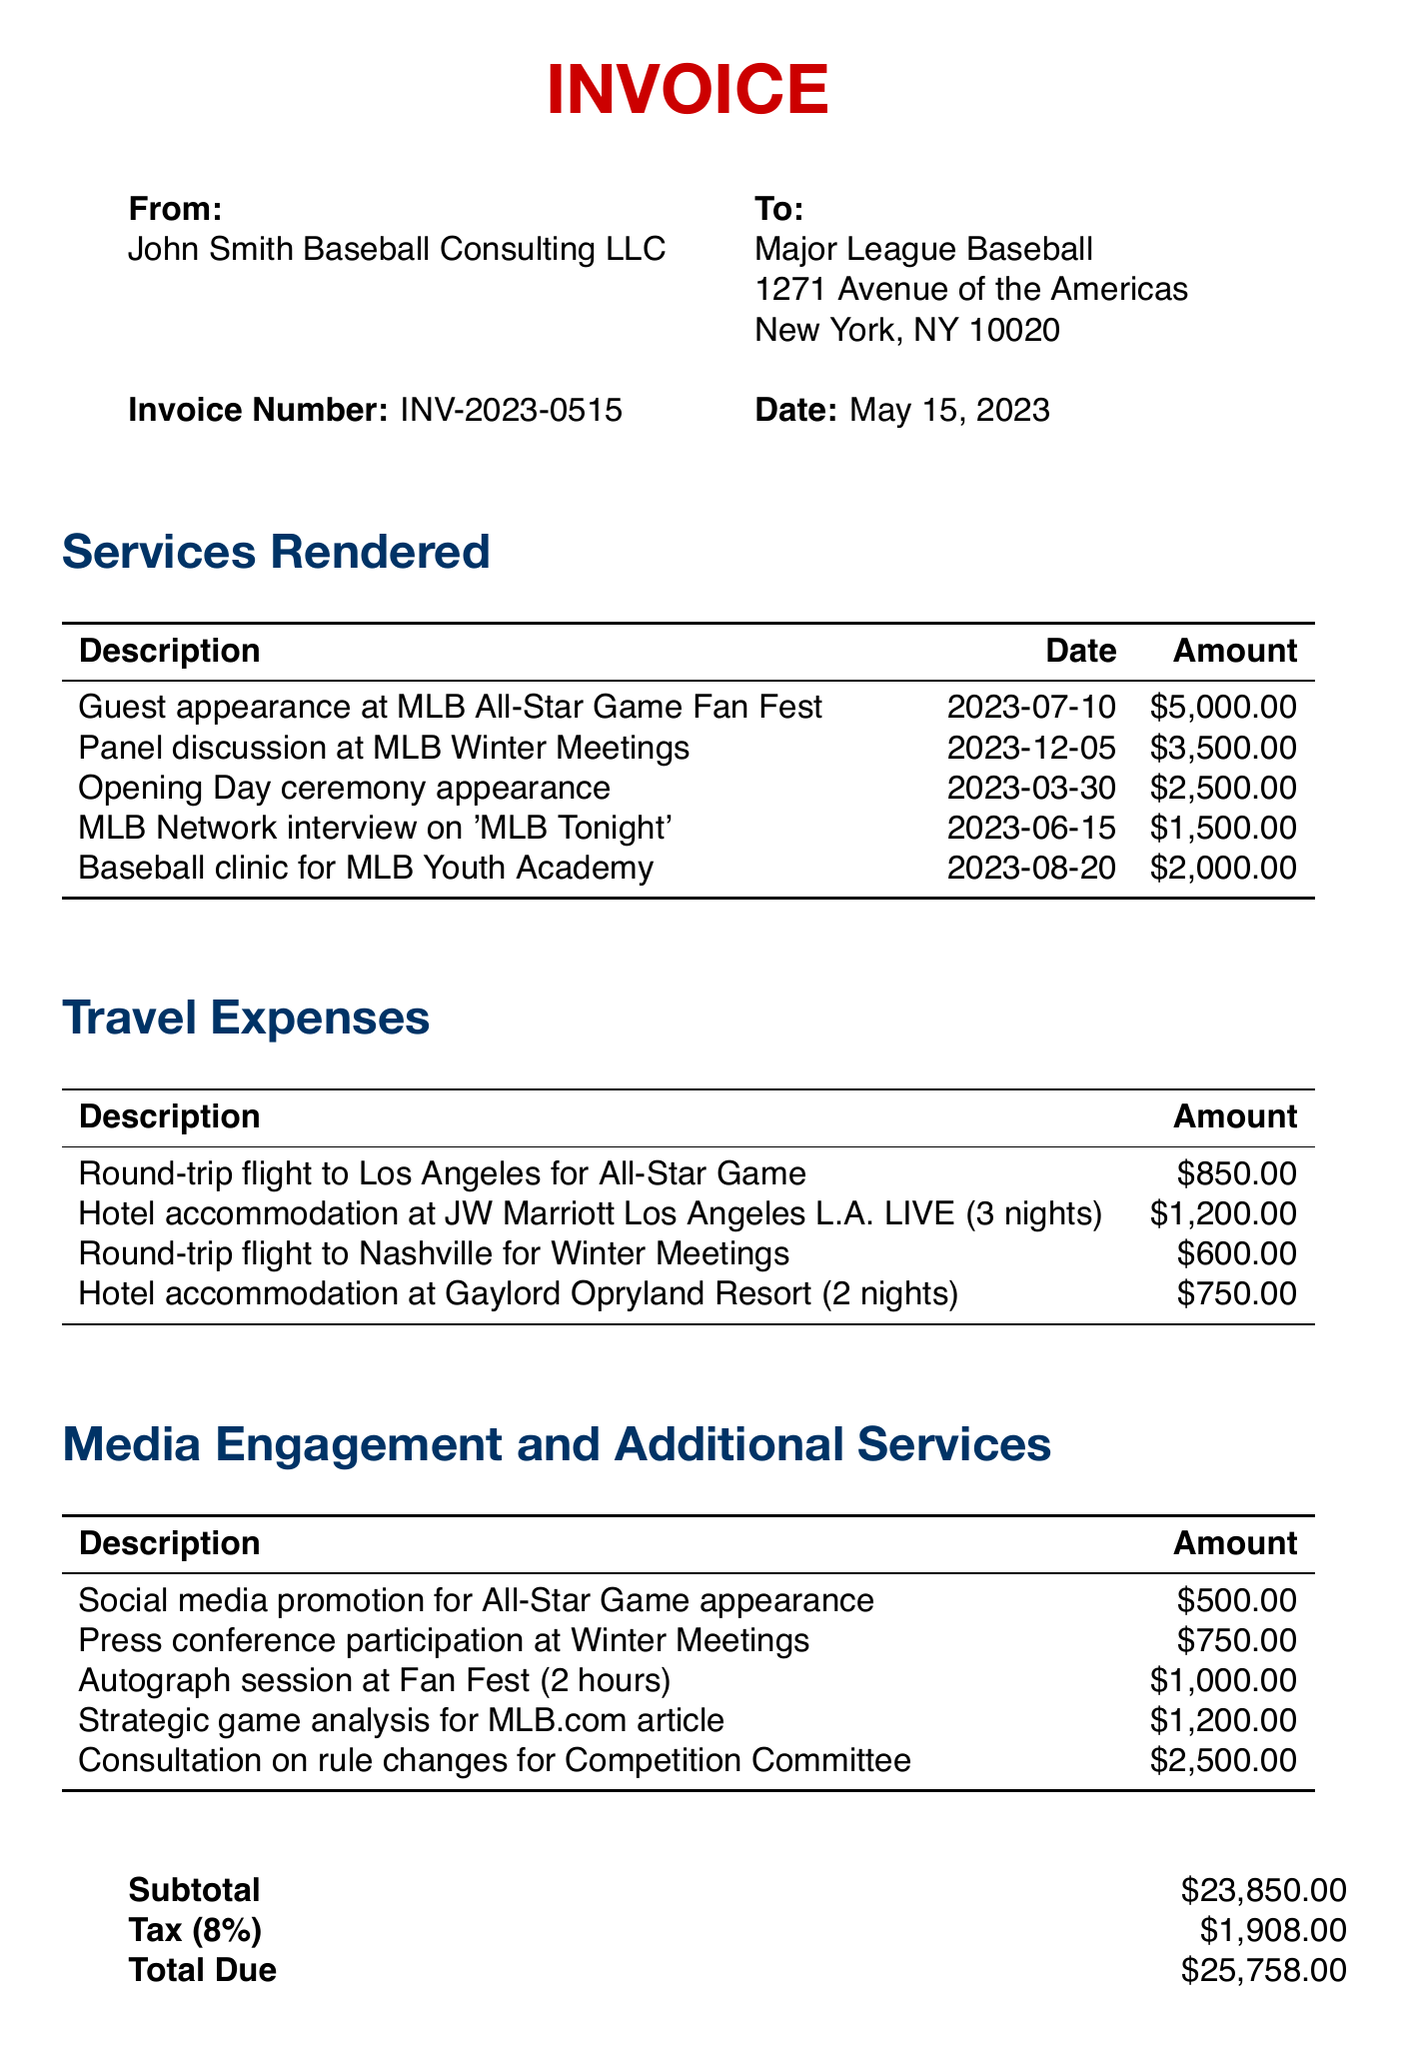What is the invoice number? The invoice number is listed in the document for identification purposes.
Answer: INV-2023-0515 What is the total amount due? The total amount due is summarized at the end of the invoice, including all services rendered, travel expenses, and taxes.
Answer: $25,758.00 How much is the appearance fee for the MLB All-Star Game Fan Fest? The appearance fee is specified in the line items under services rendered for the event.
Answer: $5,000.00 What date is the panel discussion at the MLB Winter Meetings? The date is mentioned alongside the description of the panel discussion in the invoice.
Answer: 2023-12-05 What is the amount charged for the consultation on rule changes? The charge for this service is noted in the additional services section of the invoice.
Answer: $2,500.00 How many nights was the hotel accommodation for the All-Star Game? The number of nights is indicated in the description of the hotel accommodation provided in the travel expenses.
Answer: 3 nights What company is the invoice addressed to? The recipient of the invoice is stated at the beginning in the address section.
Answer: Major League Baseball What is the tax rate applied to the subtotal? The tax rate is noted in the invoice to calculate the total tax amount.
Answer: 8% What item has the highest fee listed in the document? The item fees are detailed, allowing identification of the highest charge among services rendered.
Answer: Guest appearance at MLB All-Star Game Fan Fest 